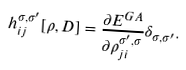<formula> <loc_0><loc_0><loc_500><loc_500>h _ { i j } ^ { \sigma , \sigma ^ { \prime } } [ \rho , D ] = \frac { \partial E ^ { G A } } { \partial \rho _ { j i } ^ { \sigma ^ { \prime } , \sigma } } \delta _ { \sigma , \sigma ^ { \prime } } .</formula> 